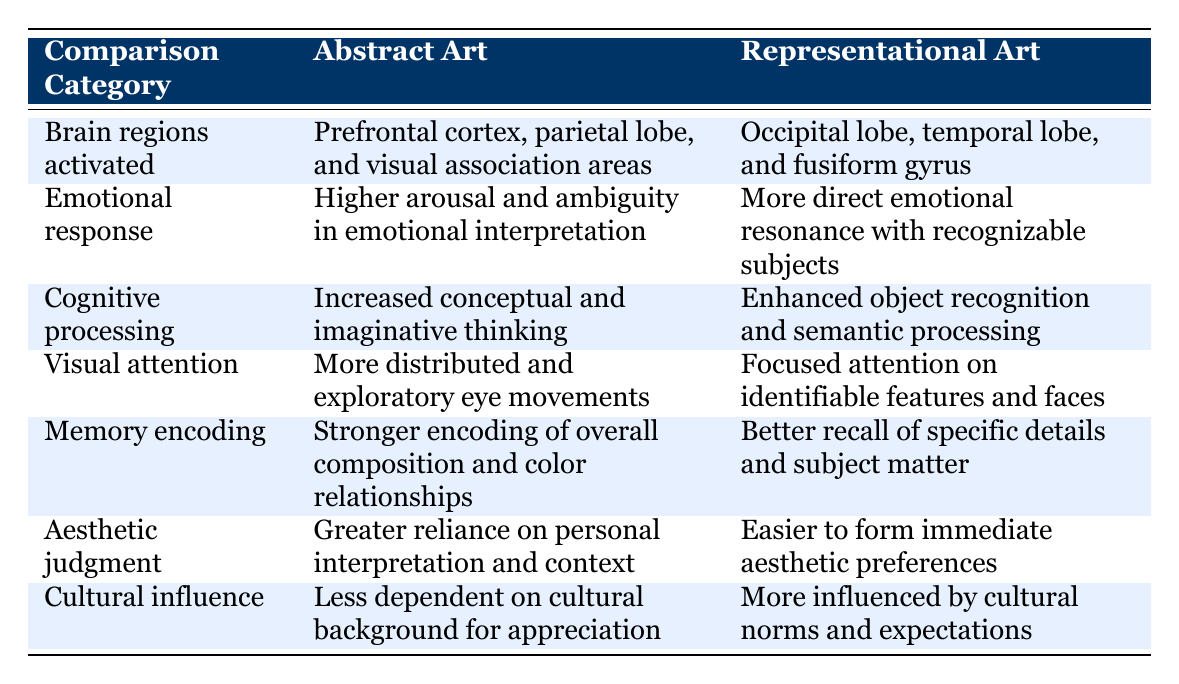What brain regions are activated by abstract art? According to the table, abstract art activates the prefrontal cortex, parietal lobe, and visual association areas.
Answer: Prefrontal cortex, parietal lobe, and visual association areas What is the emotional response to representational art? The table indicates that representational art evokes a more direct emotional resonance with recognizable subjects.
Answer: More direct emotional resonance with recognizable subjects Which type of art requires stronger memory encoding overall? The table compares memory encoding for both types of art. Abstract art shows stronger encoding of overall composition and color relationships compared to the better recall of specific details and subject matter in representational art. So, abstract art has the stronger memory encoding overall.
Answer: Abstract art Is there a difference in visual attention between the two types of art? Yes, based on the table, abstract art involves more distributed and exploratory eye movements, while representational art focuses attention on identifiable features and faces.
Answer: Yes What are the brain regions activated by representational art? The table states that representational art activates the occipital lobe, temporal lobe, and fusiform gyrus.
Answer: Occipital lobe, temporal lobe, and fusiform gyrus If someone prefers representational art, do they tend to be more influenced by cultural norms? Yes, the table states that representational art is more influenced by cultural norms and expectations compared to abstract art, which is less dependent on cultural background for appreciation.
Answer: Yes Which type of art involves increased conceptual and imaginative thinking? According to the table, abstract art involves increased conceptual and imaginative thinking, while representational art enhances object recognition and semantic processing.
Answer: Abstract art Calculate the total number of unique features in emotional responses across both types of art. The emotional responses listed are: Higher arousal and ambiguity for abstract art and more direct emotional resonance for representational art. Each type provides different emotional characteristics, leading to a total of 2 unique features of emotional response.
Answer: 2 What kind of aesthetic judgment is more prevalent in abstract art? The table notes that abstract art has a greater reliance on personal interpretation and context for aesthetic judgment compared to the easier formation of immediate aesthetic preferences found in representational art.
Answer: Greater reliance on personal interpretation and context 